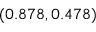Convert formula to latex. <formula><loc_0><loc_0><loc_500><loc_500>( 0 . 8 7 8 , 0 . 4 7 8 )</formula> 